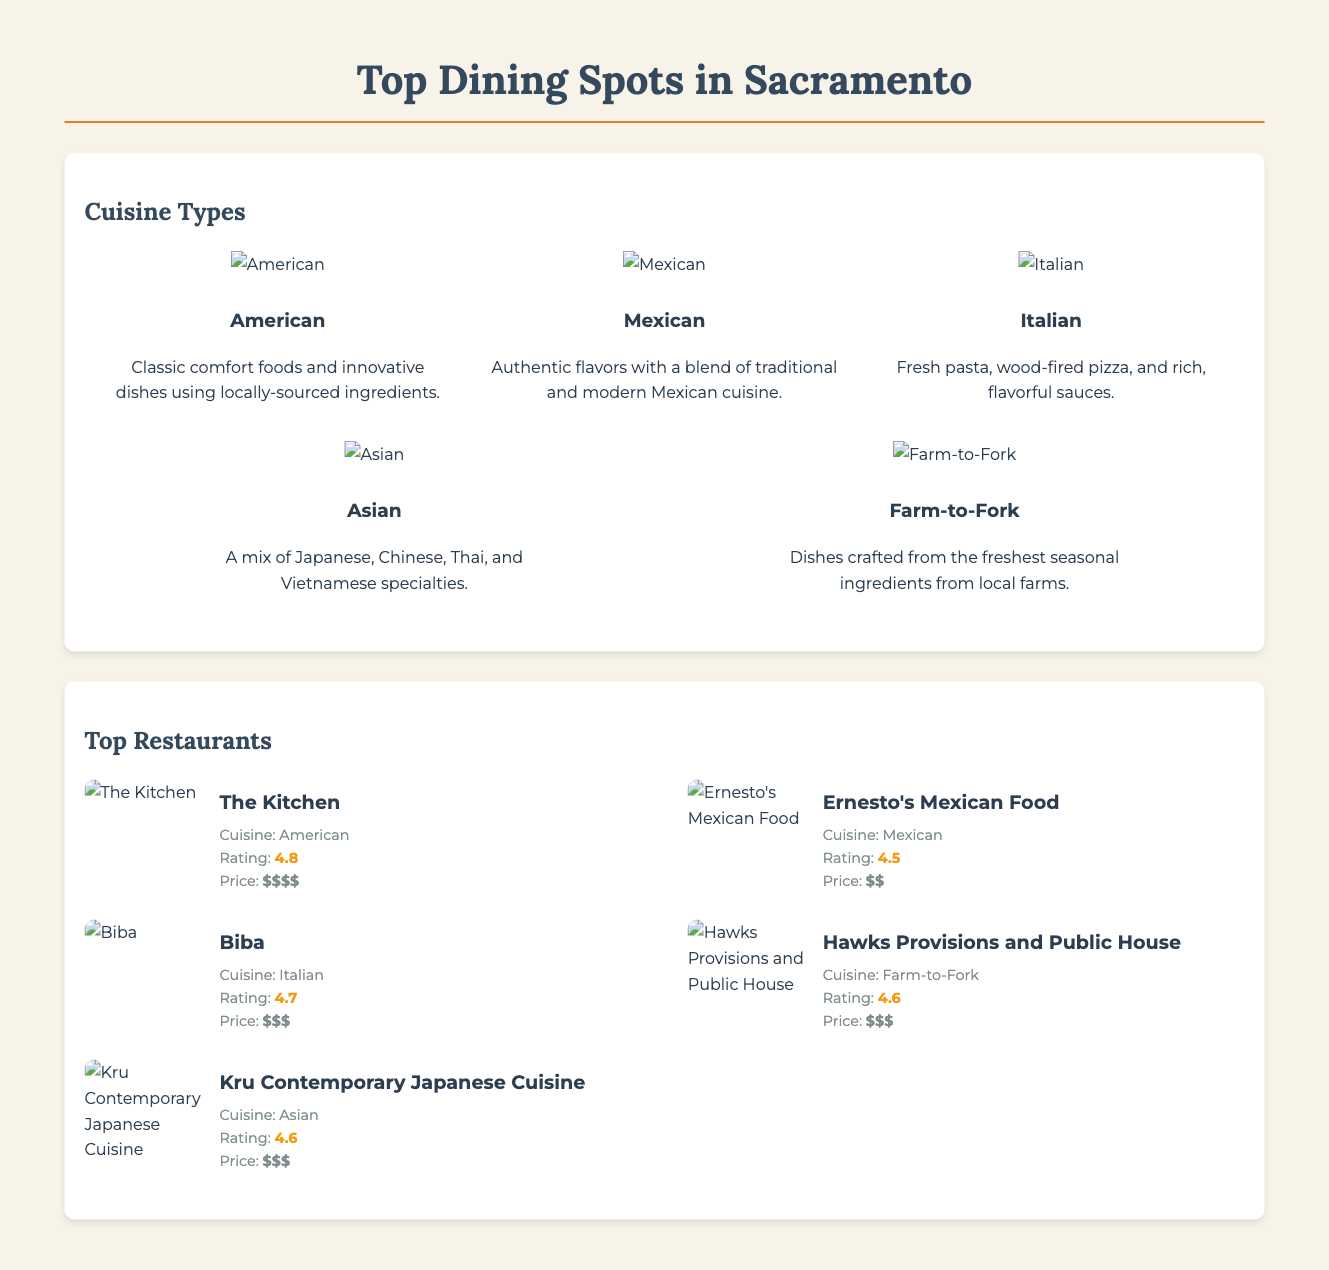What is the highest-rated restaurant in Sacramento? The highest-rated restaurant is The Kitchen with a rating of 4.8.
Answer: The Kitchen Which cuisine type features fresh pasta? The cuisine type that features fresh pasta is Italian.
Answer: Italian What price range does Ernesto's Mexican Food fall under? Ernesto's Mexican Food falls under the price range of two dollar signs, denoting moderate pricing.
Answer: $$ How many cuisine types are listed in the document? The document lists five distinct cuisine types.
Answer: 5 Which restaurant specializes in Farm-to-Fork cuisine? The restaurant that specializes in Farm-to-Fork cuisine is Hawks Provisions and Public House.
Answer: Hawks Provisions and Public House What is the average rating for Asian cuisine restaurants? The average rating for Asian cuisine restaurants, including Kru Contemporary Japanese Cuisine, is 4.6.
Answer: 4.6 What is the main theme of the document? The main theme of the document is about dining spots in Sacramento and local favorites.
Answer: Dining spots in Sacramento Which restaurant serves Mexican cuisine? The restaurant that serves Mexican cuisine is Ernesto's Mexican Food.
Answer: Ernesto's Mexican Food What is the cuisine type associated with local seasonal ingredients? The cuisine type associated with local seasonal ingredients is Farm-to-Fork.
Answer: Farm-to-Fork 